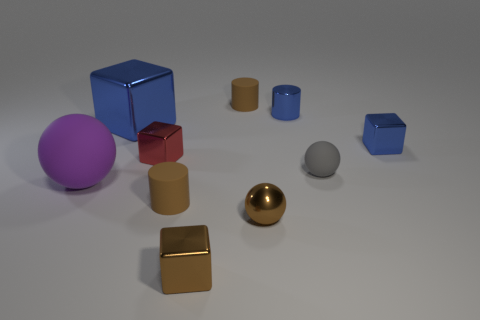Are any purple objects visible?
Your answer should be very brief. Yes. Are there more blue shiny blocks on the right side of the blue shiny cylinder than blue metal things in front of the tiny brown metal sphere?
Provide a succinct answer. Yes. There is another gray thing that is the same shape as the big matte thing; what is its material?
Give a very brief answer. Rubber. There is a cylinder that is in front of the red metallic cube; does it have the same color as the metallic sphere on the left side of the tiny matte sphere?
Offer a very short reply. Yes. What is the shape of the purple matte thing?
Provide a short and direct response. Sphere. Is the number of red blocks right of the brown metal sphere greater than the number of small purple shiny spheres?
Offer a terse response. No. The brown matte thing behind the small blue shiny cylinder has what shape?
Offer a very short reply. Cylinder. What number of other things are there of the same shape as the gray thing?
Offer a terse response. 2. Does the blue block that is to the right of the gray matte object have the same material as the brown cube?
Offer a very short reply. Yes. Is the number of tiny brown metallic objects left of the purple rubber thing the same as the number of small rubber balls to the left of the tiny blue metallic cylinder?
Provide a short and direct response. Yes. 